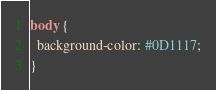<code> <loc_0><loc_0><loc_500><loc_500><_CSS_>body {
  background-color: #0D1117;
}</code> 